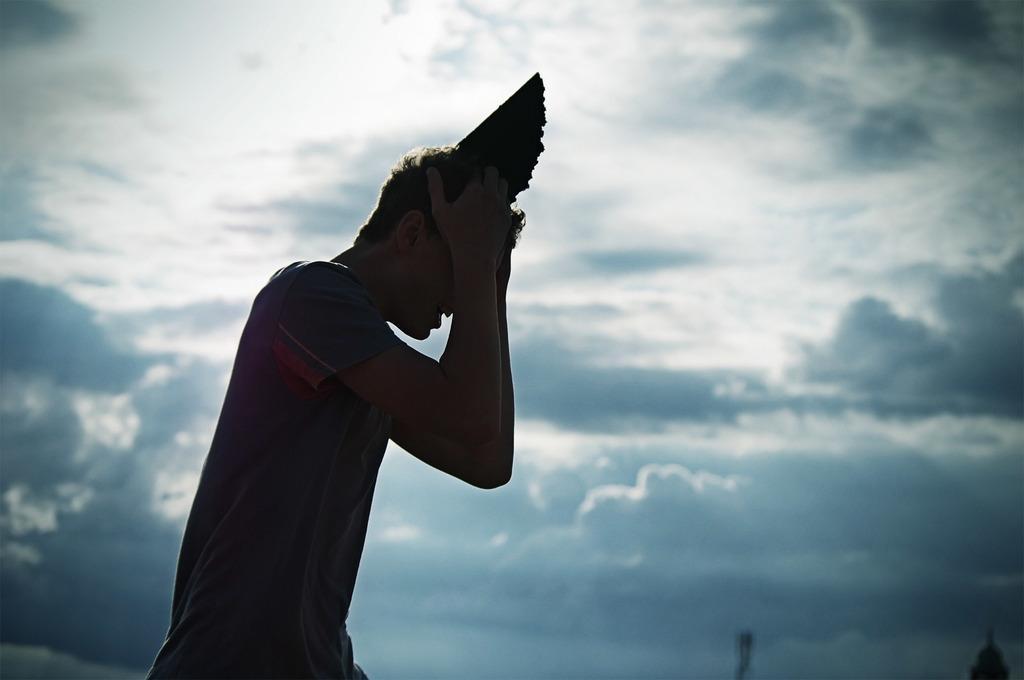Could you give a brief overview of what you see in this image? In the foreground of the picture there is a person holding his head, on the head there is an object. Sky is cloudy. 